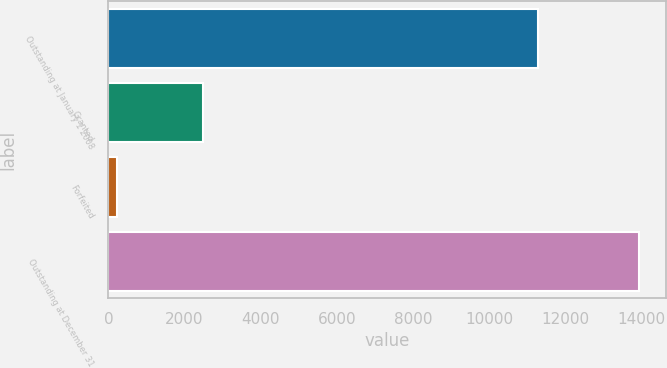Convert chart to OTSL. <chart><loc_0><loc_0><loc_500><loc_500><bar_chart><fcel>Outstanding at January 1 2008<fcel>Granted<fcel>Forfeited<fcel>Outstanding at December 31<nl><fcel>11292<fcel>2473<fcel>213<fcel>13933.4<nl></chart> 